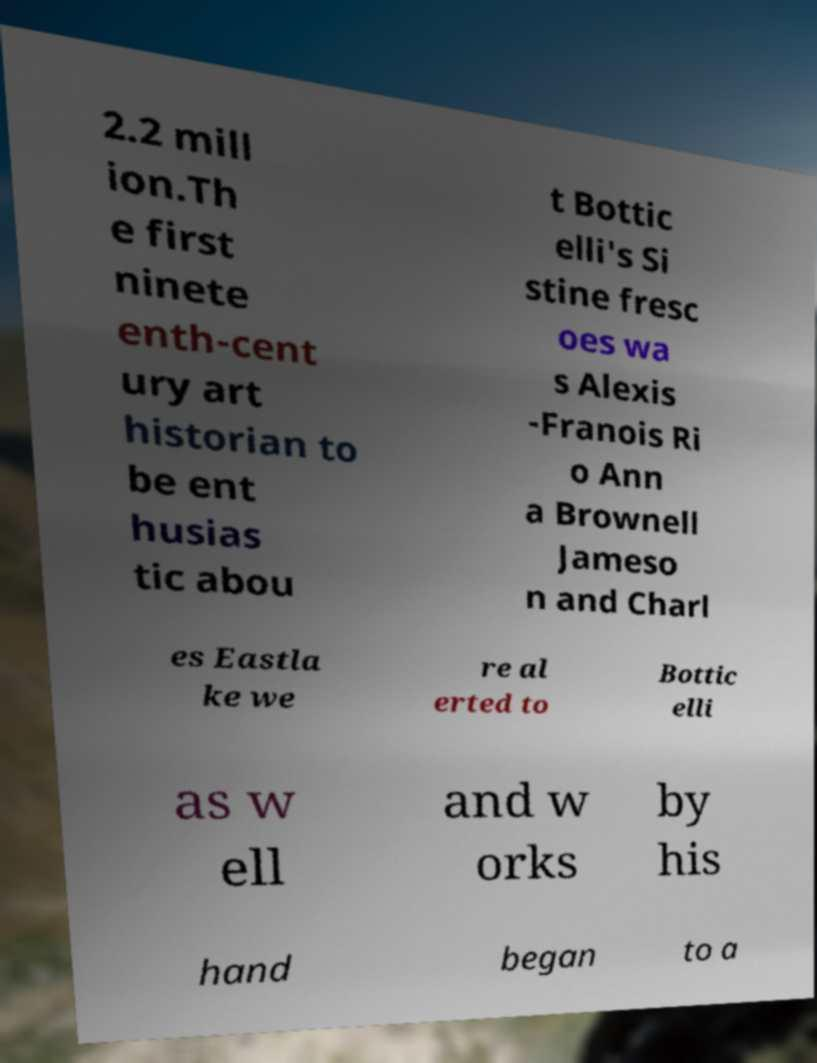For documentation purposes, I need the text within this image transcribed. Could you provide that? 2.2 mill ion.Th e first ninete enth-cent ury art historian to be ent husias tic abou t Bottic elli's Si stine fresc oes wa s Alexis -Franois Ri o Ann a Brownell Jameso n and Charl es Eastla ke we re al erted to Bottic elli as w ell and w orks by his hand began to a 